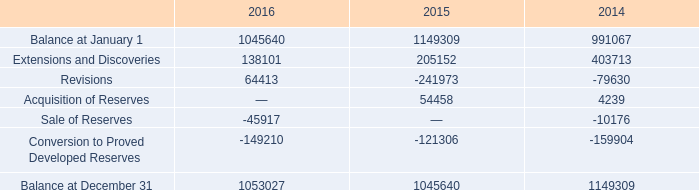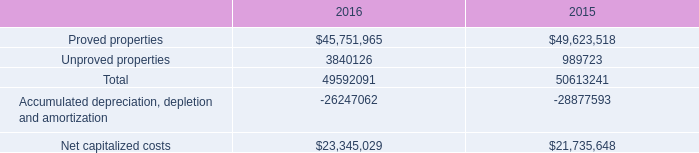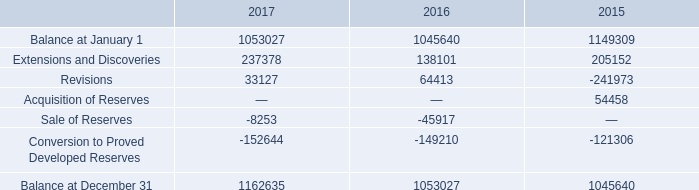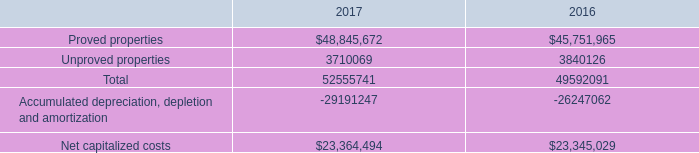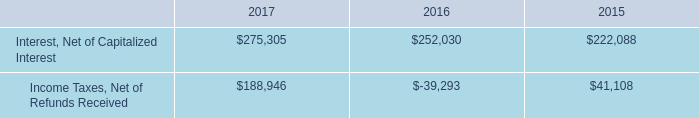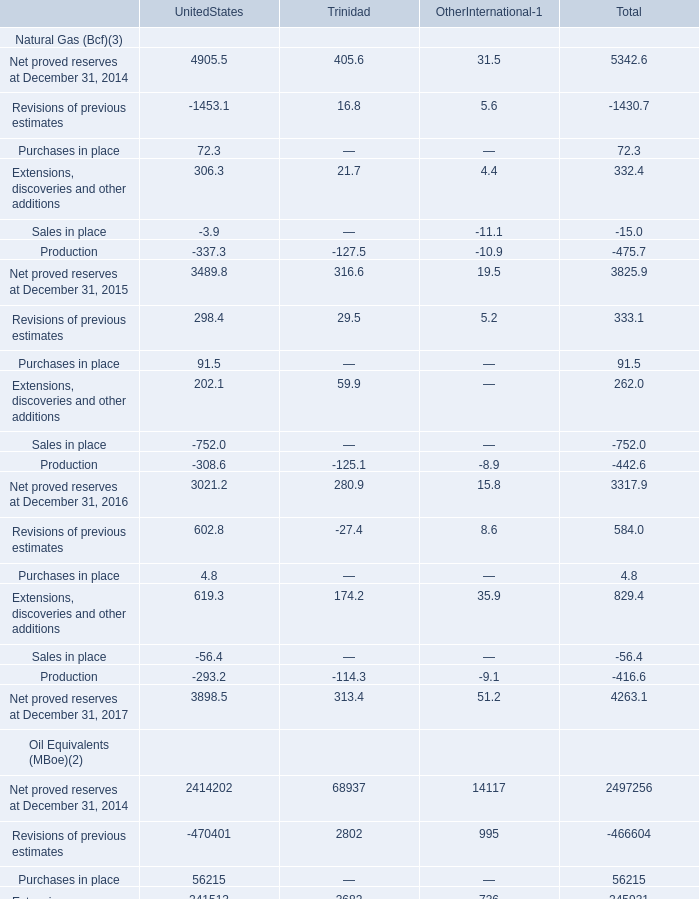What is the average amount of Conversion to Proved Developed Reserves of 2014, and Accumulated depreciation, depletion and amortization of 2016 ? 
Computations: ((159904.0 + 26247062.0) / 2)
Answer: 13203483.0. 